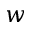Convert formula to latex. <formula><loc_0><loc_0><loc_500><loc_500>w</formula> 